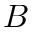<formula> <loc_0><loc_0><loc_500><loc_500>B</formula> 